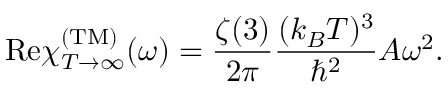Convert formula to latex. <formula><loc_0><loc_0><loc_500><loc_500>R e \chi _ { T \rightarrow \infty } ^ { ( T M ) } ( \omega ) = { \frac { \zeta ( 3 ) } { 2 \pi } } { \frac { ( k _ { B } T ) ^ { 3 } } { \hbar { ^ } { 2 } } } A \omega ^ { 2 } .</formula> 